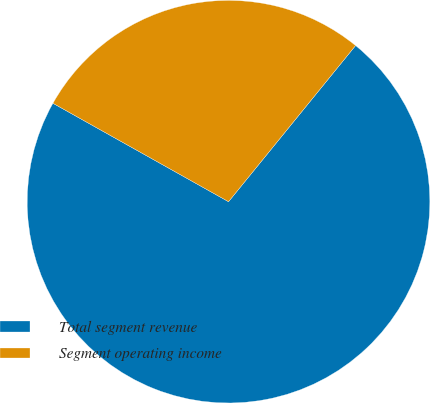Convert chart. <chart><loc_0><loc_0><loc_500><loc_500><pie_chart><fcel>Total segment revenue<fcel>Segment operating income<nl><fcel>72.26%<fcel>27.74%<nl></chart> 